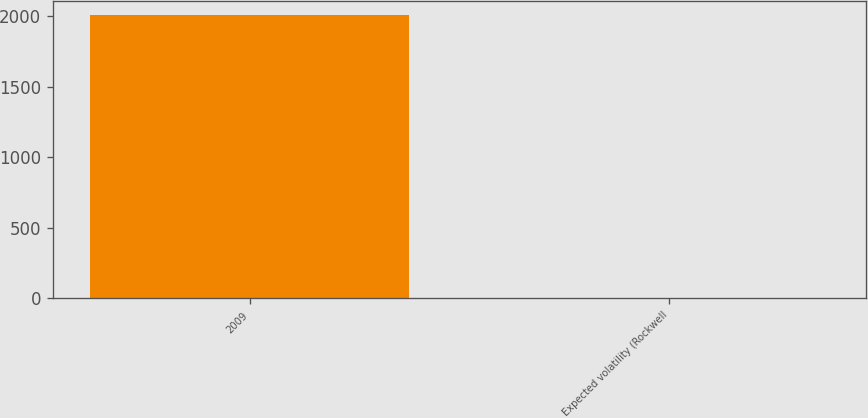Convert chart. <chart><loc_0><loc_0><loc_500><loc_500><bar_chart><fcel>2009<fcel>Expected volatility (Rockwell<nl><fcel>2008<fcel>0.27<nl></chart> 